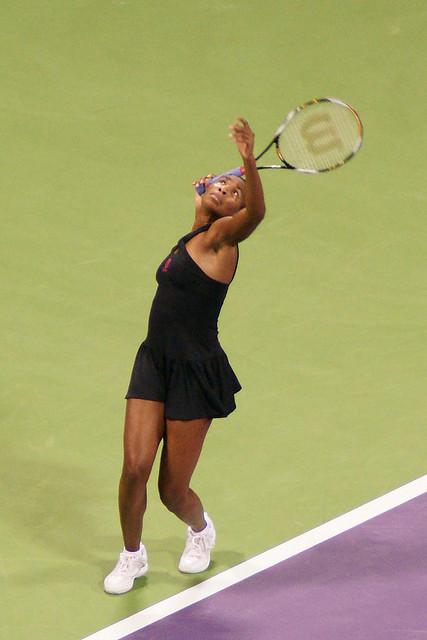Is the person wearing pink shoes?
Write a very short answer. No. What letter is woven into the tennis racquet?
Answer briefly. W. Is this an indoor tennis court?
Answer briefly. No. Is this woman in good shape?
Quick response, please. Yes. Are the player's feet on the ground?
Short answer required. Yes. Is that a man or a woman?
Keep it brief. Woman. What color is the woman wearing?
Short answer required. Black. What color is the person wearing?
Write a very short answer. Black. Where is the tennis player from?
Concise answer only. America. Is there a tennis ball in the foreground?
Be succinct. No. Is this woman famous?
Keep it brief. Yes. Which type of tennis shot is this woman about to perform, if she is right-handed?
Answer briefly. Serve. How many feet does this person have on the ground?
Keep it brief. 2. What color is the tennis court?
Give a very brief answer. Green and purple. What color is the court?
Short answer required. Purple. What is the female playing?
Be succinct. Tennis. 